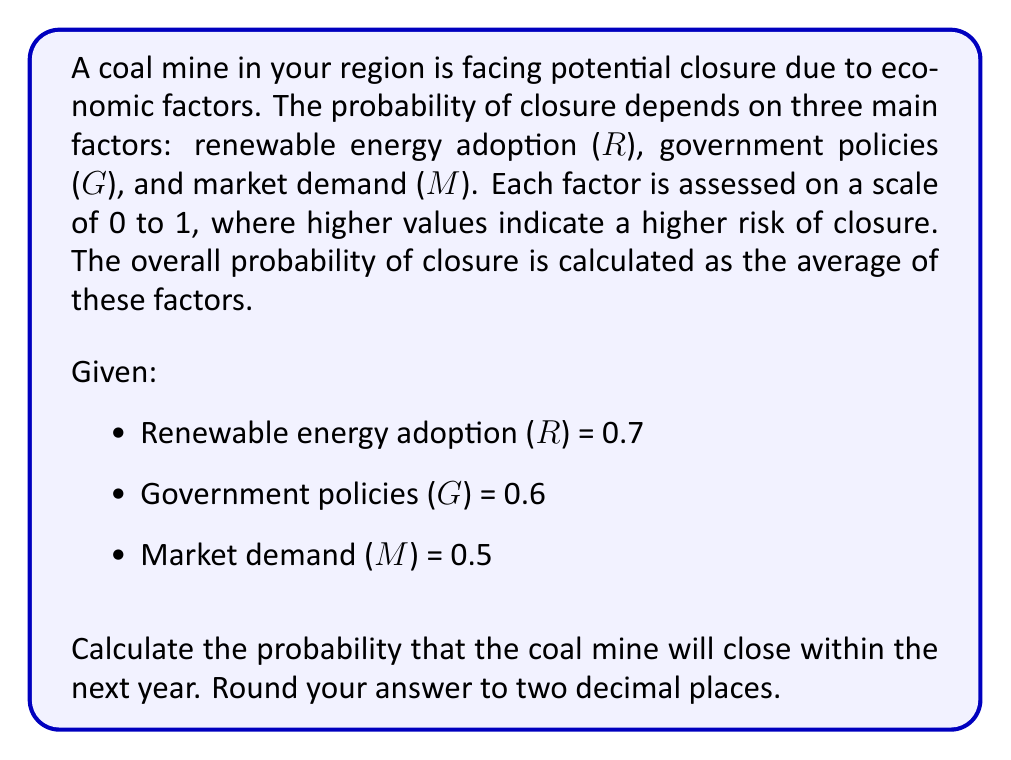What is the answer to this math problem? To solve this problem, we need to follow these steps:

1. Understand the given information:
   - Three factors affect the probability of closure: R, G, and M
   - Each factor is rated on a scale of 0 to 1
   - The overall probability is the average of these factors

2. Calculate the average of the three factors:
   
   $$P(\text{closure}) = \frac{R + G + M}{3}$$

3. Substitute the given values:
   
   $$P(\text{closure}) = \frac{0.7 + 0.6 + 0.5}{3}$$

4. Perform the calculation:
   
   $$P(\text{closure}) = \frac{1.8}{3} = 0.6$$

5. Round the result to two decimal places:
   
   $$P(\text{closure}) = 0.60$$

Therefore, the probability that the coal mine will close within the next year is 0.60 or 60%.
Answer: 0.60 